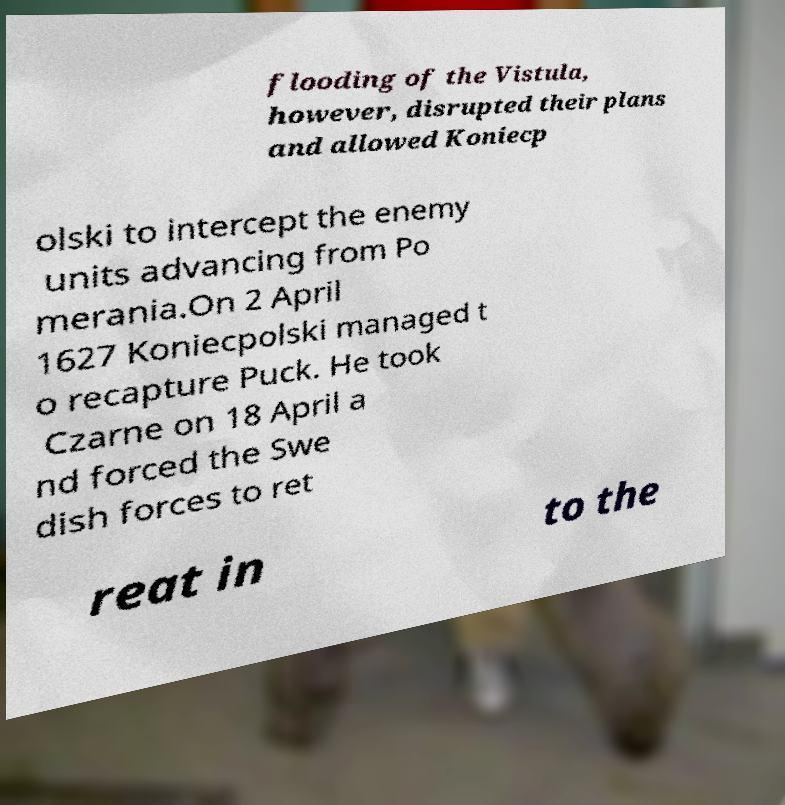There's text embedded in this image that I need extracted. Can you transcribe it verbatim? flooding of the Vistula, however, disrupted their plans and allowed Koniecp olski to intercept the enemy units advancing from Po merania.On 2 April 1627 Koniecpolski managed t o recapture Puck. He took Czarne on 18 April a nd forced the Swe dish forces to ret reat in to the 